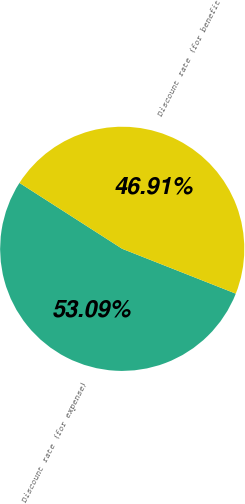Convert chart. <chart><loc_0><loc_0><loc_500><loc_500><pie_chart><fcel>Discount rate (for expense)<fcel>Discount rate (for benefit<nl><fcel>53.09%<fcel>46.91%<nl></chart> 